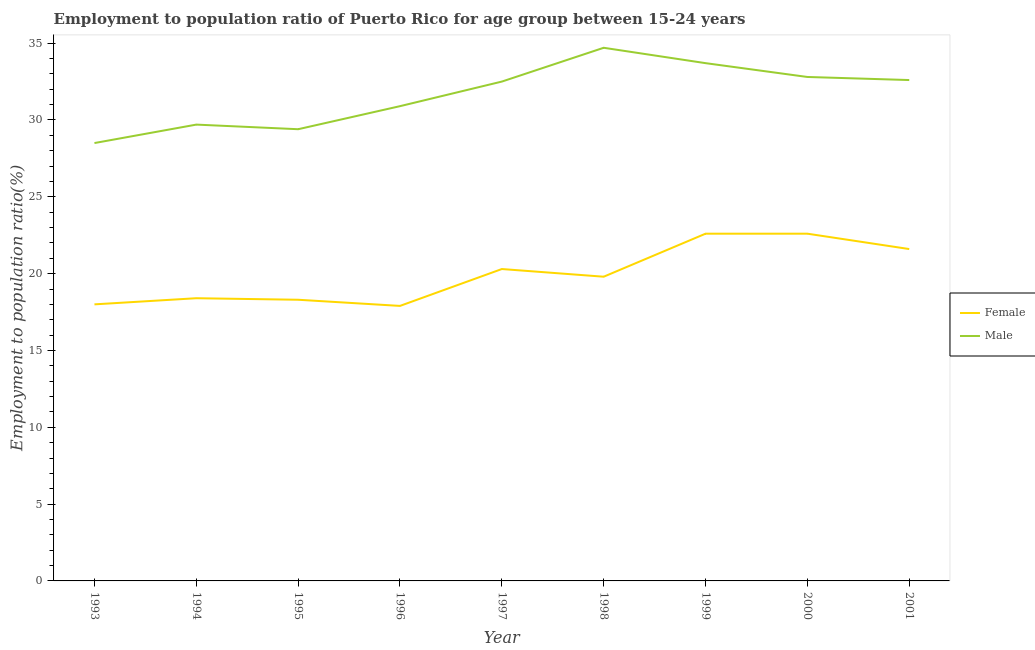How many different coloured lines are there?
Keep it short and to the point. 2. Does the line corresponding to employment to population ratio(female) intersect with the line corresponding to employment to population ratio(male)?
Keep it short and to the point. No. Is the number of lines equal to the number of legend labels?
Keep it short and to the point. Yes. What is the employment to population ratio(male) in 1993?
Your answer should be compact. 28.5. Across all years, what is the maximum employment to population ratio(female)?
Your response must be concise. 22.6. Across all years, what is the minimum employment to population ratio(female)?
Provide a short and direct response. 17.9. In which year was the employment to population ratio(female) minimum?
Your answer should be very brief. 1996. What is the total employment to population ratio(male) in the graph?
Your response must be concise. 284.8. What is the difference between the employment to population ratio(male) in 1995 and that in 2000?
Give a very brief answer. -3.4. What is the difference between the employment to population ratio(female) in 1996 and the employment to population ratio(male) in 2001?
Give a very brief answer. -14.7. What is the average employment to population ratio(female) per year?
Your answer should be compact. 19.94. In the year 1998, what is the difference between the employment to population ratio(male) and employment to population ratio(female)?
Your answer should be compact. 14.9. What is the ratio of the employment to population ratio(male) in 1994 to that in 2000?
Ensure brevity in your answer.  0.91. Is the employment to population ratio(female) in 1995 less than that in 1999?
Offer a terse response. Yes. Is the difference between the employment to population ratio(male) in 1996 and 1998 greater than the difference between the employment to population ratio(female) in 1996 and 1998?
Make the answer very short. No. What is the difference between the highest and the second highest employment to population ratio(female)?
Ensure brevity in your answer.  0. What is the difference between the highest and the lowest employment to population ratio(male)?
Keep it short and to the point. 6.2. In how many years, is the employment to population ratio(female) greater than the average employment to population ratio(female) taken over all years?
Offer a terse response. 4. Is the sum of the employment to population ratio(male) in 1995 and 1999 greater than the maximum employment to population ratio(female) across all years?
Ensure brevity in your answer.  Yes. Is the employment to population ratio(female) strictly greater than the employment to population ratio(male) over the years?
Offer a very short reply. No. Is the employment to population ratio(female) strictly less than the employment to population ratio(male) over the years?
Offer a very short reply. Yes. How many years are there in the graph?
Ensure brevity in your answer.  9. Are the values on the major ticks of Y-axis written in scientific E-notation?
Make the answer very short. No. Does the graph contain grids?
Offer a terse response. No. Where does the legend appear in the graph?
Give a very brief answer. Center right. How many legend labels are there?
Ensure brevity in your answer.  2. How are the legend labels stacked?
Offer a very short reply. Vertical. What is the title of the graph?
Keep it short and to the point. Employment to population ratio of Puerto Rico for age group between 15-24 years. What is the label or title of the X-axis?
Offer a very short reply. Year. What is the Employment to population ratio(%) in Female in 1993?
Ensure brevity in your answer.  18. What is the Employment to population ratio(%) of Female in 1994?
Your response must be concise. 18.4. What is the Employment to population ratio(%) in Male in 1994?
Ensure brevity in your answer.  29.7. What is the Employment to population ratio(%) of Female in 1995?
Make the answer very short. 18.3. What is the Employment to population ratio(%) in Male in 1995?
Ensure brevity in your answer.  29.4. What is the Employment to population ratio(%) of Female in 1996?
Offer a very short reply. 17.9. What is the Employment to population ratio(%) of Male in 1996?
Your answer should be very brief. 30.9. What is the Employment to population ratio(%) of Female in 1997?
Your answer should be very brief. 20.3. What is the Employment to population ratio(%) in Male in 1997?
Make the answer very short. 32.5. What is the Employment to population ratio(%) in Female in 1998?
Give a very brief answer. 19.8. What is the Employment to population ratio(%) in Male in 1998?
Keep it short and to the point. 34.7. What is the Employment to population ratio(%) of Female in 1999?
Your answer should be compact. 22.6. What is the Employment to population ratio(%) of Male in 1999?
Provide a succinct answer. 33.7. What is the Employment to population ratio(%) in Female in 2000?
Offer a very short reply. 22.6. What is the Employment to population ratio(%) in Male in 2000?
Give a very brief answer. 32.8. What is the Employment to population ratio(%) in Female in 2001?
Your response must be concise. 21.6. What is the Employment to population ratio(%) in Male in 2001?
Your response must be concise. 32.6. Across all years, what is the maximum Employment to population ratio(%) in Female?
Provide a short and direct response. 22.6. Across all years, what is the maximum Employment to population ratio(%) in Male?
Offer a terse response. 34.7. Across all years, what is the minimum Employment to population ratio(%) in Female?
Provide a succinct answer. 17.9. What is the total Employment to population ratio(%) in Female in the graph?
Your response must be concise. 179.5. What is the total Employment to population ratio(%) of Male in the graph?
Give a very brief answer. 284.8. What is the difference between the Employment to population ratio(%) of Male in 1993 and that in 1995?
Offer a very short reply. -0.9. What is the difference between the Employment to population ratio(%) in Male in 1993 and that in 1996?
Provide a short and direct response. -2.4. What is the difference between the Employment to population ratio(%) in Male in 1993 and that in 1997?
Ensure brevity in your answer.  -4. What is the difference between the Employment to population ratio(%) in Female in 1993 and that in 2000?
Provide a short and direct response. -4.6. What is the difference between the Employment to population ratio(%) of Male in 1993 and that in 2000?
Your answer should be compact. -4.3. What is the difference between the Employment to population ratio(%) in Female in 1993 and that in 2001?
Your answer should be compact. -3.6. What is the difference between the Employment to population ratio(%) of Female in 1994 and that in 1995?
Ensure brevity in your answer.  0.1. What is the difference between the Employment to population ratio(%) in Male in 1994 and that in 1995?
Your response must be concise. 0.3. What is the difference between the Employment to population ratio(%) of Male in 1994 and that in 1996?
Ensure brevity in your answer.  -1.2. What is the difference between the Employment to population ratio(%) in Female in 1994 and that in 1997?
Offer a terse response. -1.9. What is the difference between the Employment to population ratio(%) of Male in 1994 and that in 1997?
Make the answer very short. -2.8. What is the difference between the Employment to population ratio(%) of Female in 1994 and that in 2001?
Offer a very short reply. -3.2. What is the difference between the Employment to population ratio(%) of Male in 1995 and that in 1996?
Your response must be concise. -1.5. What is the difference between the Employment to population ratio(%) of Female in 1995 and that in 1997?
Provide a short and direct response. -2. What is the difference between the Employment to population ratio(%) of Male in 1995 and that in 1997?
Keep it short and to the point. -3.1. What is the difference between the Employment to population ratio(%) of Male in 1995 and that in 1999?
Make the answer very short. -4.3. What is the difference between the Employment to population ratio(%) of Female in 1995 and that in 2000?
Offer a very short reply. -4.3. What is the difference between the Employment to population ratio(%) of Male in 1995 and that in 2000?
Your response must be concise. -3.4. What is the difference between the Employment to population ratio(%) of Female in 1995 and that in 2001?
Ensure brevity in your answer.  -3.3. What is the difference between the Employment to population ratio(%) of Male in 1995 and that in 2001?
Offer a terse response. -3.2. What is the difference between the Employment to population ratio(%) in Male in 1996 and that in 1997?
Make the answer very short. -1.6. What is the difference between the Employment to population ratio(%) in Female in 1996 and that in 1998?
Give a very brief answer. -1.9. What is the difference between the Employment to population ratio(%) of Male in 1996 and that in 1998?
Make the answer very short. -3.8. What is the difference between the Employment to population ratio(%) in Female in 1996 and that in 1999?
Your answer should be very brief. -4.7. What is the difference between the Employment to population ratio(%) of Male in 1996 and that in 2001?
Offer a very short reply. -1.7. What is the difference between the Employment to population ratio(%) of Female in 1997 and that in 1998?
Give a very brief answer. 0.5. What is the difference between the Employment to population ratio(%) of Male in 1997 and that in 1998?
Ensure brevity in your answer.  -2.2. What is the difference between the Employment to population ratio(%) in Male in 1997 and that in 2000?
Provide a short and direct response. -0.3. What is the difference between the Employment to population ratio(%) of Female in 1997 and that in 2001?
Offer a terse response. -1.3. What is the difference between the Employment to population ratio(%) in Female in 1998 and that in 1999?
Your answer should be compact. -2.8. What is the difference between the Employment to population ratio(%) in Female in 1998 and that in 2001?
Give a very brief answer. -1.8. What is the difference between the Employment to population ratio(%) of Male in 1998 and that in 2001?
Ensure brevity in your answer.  2.1. What is the difference between the Employment to population ratio(%) of Male in 1999 and that in 2000?
Make the answer very short. 0.9. What is the difference between the Employment to population ratio(%) in Female in 1999 and that in 2001?
Give a very brief answer. 1. What is the difference between the Employment to population ratio(%) in Female in 1993 and the Employment to population ratio(%) in Male in 1995?
Offer a terse response. -11.4. What is the difference between the Employment to population ratio(%) of Female in 1993 and the Employment to population ratio(%) of Male in 1996?
Offer a very short reply. -12.9. What is the difference between the Employment to population ratio(%) of Female in 1993 and the Employment to population ratio(%) of Male in 1998?
Your answer should be compact. -16.7. What is the difference between the Employment to population ratio(%) in Female in 1993 and the Employment to population ratio(%) in Male in 1999?
Your answer should be very brief. -15.7. What is the difference between the Employment to population ratio(%) of Female in 1993 and the Employment to population ratio(%) of Male in 2000?
Provide a succinct answer. -14.8. What is the difference between the Employment to population ratio(%) of Female in 1993 and the Employment to population ratio(%) of Male in 2001?
Your answer should be compact. -14.6. What is the difference between the Employment to population ratio(%) in Female in 1994 and the Employment to population ratio(%) in Male in 1997?
Provide a succinct answer. -14.1. What is the difference between the Employment to population ratio(%) in Female in 1994 and the Employment to population ratio(%) in Male in 1998?
Give a very brief answer. -16.3. What is the difference between the Employment to population ratio(%) in Female in 1994 and the Employment to population ratio(%) in Male in 1999?
Provide a short and direct response. -15.3. What is the difference between the Employment to population ratio(%) of Female in 1994 and the Employment to population ratio(%) of Male in 2000?
Your answer should be compact. -14.4. What is the difference between the Employment to population ratio(%) in Female in 1994 and the Employment to population ratio(%) in Male in 2001?
Your response must be concise. -14.2. What is the difference between the Employment to population ratio(%) of Female in 1995 and the Employment to population ratio(%) of Male in 1998?
Provide a succinct answer. -16.4. What is the difference between the Employment to population ratio(%) of Female in 1995 and the Employment to population ratio(%) of Male in 1999?
Provide a succinct answer. -15.4. What is the difference between the Employment to population ratio(%) in Female in 1995 and the Employment to population ratio(%) in Male in 2001?
Provide a succinct answer. -14.3. What is the difference between the Employment to population ratio(%) in Female in 1996 and the Employment to population ratio(%) in Male in 1997?
Your answer should be compact. -14.6. What is the difference between the Employment to population ratio(%) in Female in 1996 and the Employment to population ratio(%) in Male in 1998?
Make the answer very short. -16.8. What is the difference between the Employment to population ratio(%) in Female in 1996 and the Employment to population ratio(%) in Male in 1999?
Your answer should be very brief. -15.8. What is the difference between the Employment to population ratio(%) in Female in 1996 and the Employment to population ratio(%) in Male in 2000?
Provide a succinct answer. -14.9. What is the difference between the Employment to population ratio(%) in Female in 1996 and the Employment to population ratio(%) in Male in 2001?
Your answer should be compact. -14.7. What is the difference between the Employment to population ratio(%) of Female in 1997 and the Employment to population ratio(%) of Male in 1998?
Keep it short and to the point. -14.4. What is the difference between the Employment to population ratio(%) in Female in 1997 and the Employment to population ratio(%) in Male in 1999?
Make the answer very short. -13.4. What is the difference between the Employment to population ratio(%) of Female in 1997 and the Employment to population ratio(%) of Male in 2000?
Make the answer very short. -12.5. What is the difference between the Employment to population ratio(%) in Female in 1997 and the Employment to population ratio(%) in Male in 2001?
Your answer should be compact. -12.3. What is the difference between the Employment to population ratio(%) in Female in 1998 and the Employment to population ratio(%) in Male in 2000?
Your answer should be very brief. -13. What is the difference between the Employment to population ratio(%) of Female in 1999 and the Employment to population ratio(%) of Male in 2000?
Your answer should be very brief. -10.2. What is the difference between the Employment to population ratio(%) in Female in 1999 and the Employment to population ratio(%) in Male in 2001?
Provide a short and direct response. -10. What is the average Employment to population ratio(%) of Female per year?
Offer a terse response. 19.94. What is the average Employment to population ratio(%) in Male per year?
Give a very brief answer. 31.64. In the year 1995, what is the difference between the Employment to population ratio(%) of Female and Employment to population ratio(%) of Male?
Offer a terse response. -11.1. In the year 1998, what is the difference between the Employment to population ratio(%) of Female and Employment to population ratio(%) of Male?
Provide a short and direct response. -14.9. In the year 2000, what is the difference between the Employment to population ratio(%) of Female and Employment to population ratio(%) of Male?
Your response must be concise. -10.2. In the year 2001, what is the difference between the Employment to population ratio(%) of Female and Employment to population ratio(%) of Male?
Your response must be concise. -11. What is the ratio of the Employment to population ratio(%) in Female in 1993 to that in 1994?
Offer a very short reply. 0.98. What is the ratio of the Employment to population ratio(%) in Male in 1993 to that in 1994?
Offer a very short reply. 0.96. What is the ratio of the Employment to population ratio(%) of Female in 1993 to that in 1995?
Ensure brevity in your answer.  0.98. What is the ratio of the Employment to population ratio(%) in Male in 1993 to that in 1995?
Offer a terse response. 0.97. What is the ratio of the Employment to population ratio(%) of Female in 1993 to that in 1996?
Provide a succinct answer. 1.01. What is the ratio of the Employment to population ratio(%) in Male in 1993 to that in 1996?
Your answer should be compact. 0.92. What is the ratio of the Employment to population ratio(%) in Female in 1993 to that in 1997?
Your answer should be very brief. 0.89. What is the ratio of the Employment to population ratio(%) in Male in 1993 to that in 1997?
Your answer should be very brief. 0.88. What is the ratio of the Employment to population ratio(%) of Male in 1993 to that in 1998?
Make the answer very short. 0.82. What is the ratio of the Employment to population ratio(%) in Female in 1993 to that in 1999?
Offer a terse response. 0.8. What is the ratio of the Employment to population ratio(%) in Male in 1993 to that in 1999?
Provide a succinct answer. 0.85. What is the ratio of the Employment to population ratio(%) of Female in 1993 to that in 2000?
Make the answer very short. 0.8. What is the ratio of the Employment to population ratio(%) of Male in 1993 to that in 2000?
Provide a succinct answer. 0.87. What is the ratio of the Employment to population ratio(%) of Female in 1993 to that in 2001?
Offer a terse response. 0.83. What is the ratio of the Employment to population ratio(%) in Male in 1993 to that in 2001?
Provide a short and direct response. 0.87. What is the ratio of the Employment to population ratio(%) of Female in 1994 to that in 1995?
Give a very brief answer. 1.01. What is the ratio of the Employment to population ratio(%) in Male in 1994 to that in 1995?
Offer a terse response. 1.01. What is the ratio of the Employment to population ratio(%) in Female in 1994 to that in 1996?
Your answer should be compact. 1.03. What is the ratio of the Employment to population ratio(%) in Male in 1994 to that in 1996?
Keep it short and to the point. 0.96. What is the ratio of the Employment to population ratio(%) in Female in 1994 to that in 1997?
Give a very brief answer. 0.91. What is the ratio of the Employment to population ratio(%) of Male in 1994 to that in 1997?
Your response must be concise. 0.91. What is the ratio of the Employment to population ratio(%) of Female in 1994 to that in 1998?
Ensure brevity in your answer.  0.93. What is the ratio of the Employment to population ratio(%) of Male in 1994 to that in 1998?
Your answer should be compact. 0.86. What is the ratio of the Employment to population ratio(%) of Female in 1994 to that in 1999?
Offer a terse response. 0.81. What is the ratio of the Employment to population ratio(%) in Male in 1994 to that in 1999?
Offer a very short reply. 0.88. What is the ratio of the Employment to population ratio(%) in Female in 1994 to that in 2000?
Your answer should be very brief. 0.81. What is the ratio of the Employment to population ratio(%) of Male in 1994 to that in 2000?
Ensure brevity in your answer.  0.91. What is the ratio of the Employment to population ratio(%) of Female in 1994 to that in 2001?
Your response must be concise. 0.85. What is the ratio of the Employment to population ratio(%) of Male in 1994 to that in 2001?
Your answer should be compact. 0.91. What is the ratio of the Employment to population ratio(%) of Female in 1995 to that in 1996?
Your answer should be very brief. 1.02. What is the ratio of the Employment to population ratio(%) in Male in 1995 to that in 1996?
Your answer should be compact. 0.95. What is the ratio of the Employment to population ratio(%) of Female in 1995 to that in 1997?
Your answer should be very brief. 0.9. What is the ratio of the Employment to population ratio(%) in Male in 1995 to that in 1997?
Your response must be concise. 0.9. What is the ratio of the Employment to population ratio(%) in Female in 1995 to that in 1998?
Keep it short and to the point. 0.92. What is the ratio of the Employment to population ratio(%) in Male in 1995 to that in 1998?
Make the answer very short. 0.85. What is the ratio of the Employment to population ratio(%) of Female in 1995 to that in 1999?
Keep it short and to the point. 0.81. What is the ratio of the Employment to population ratio(%) in Male in 1995 to that in 1999?
Your answer should be very brief. 0.87. What is the ratio of the Employment to population ratio(%) in Female in 1995 to that in 2000?
Ensure brevity in your answer.  0.81. What is the ratio of the Employment to population ratio(%) in Male in 1995 to that in 2000?
Make the answer very short. 0.9. What is the ratio of the Employment to population ratio(%) of Female in 1995 to that in 2001?
Keep it short and to the point. 0.85. What is the ratio of the Employment to population ratio(%) of Male in 1995 to that in 2001?
Ensure brevity in your answer.  0.9. What is the ratio of the Employment to population ratio(%) in Female in 1996 to that in 1997?
Give a very brief answer. 0.88. What is the ratio of the Employment to population ratio(%) in Male in 1996 to that in 1997?
Ensure brevity in your answer.  0.95. What is the ratio of the Employment to population ratio(%) of Female in 1996 to that in 1998?
Offer a terse response. 0.9. What is the ratio of the Employment to population ratio(%) in Male in 1996 to that in 1998?
Make the answer very short. 0.89. What is the ratio of the Employment to population ratio(%) of Female in 1996 to that in 1999?
Make the answer very short. 0.79. What is the ratio of the Employment to population ratio(%) in Male in 1996 to that in 1999?
Offer a terse response. 0.92. What is the ratio of the Employment to population ratio(%) of Female in 1996 to that in 2000?
Your response must be concise. 0.79. What is the ratio of the Employment to population ratio(%) in Male in 1996 to that in 2000?
Give a very brief answer. 0.94. What is the ratio of the Employment to population ratio(%) of Female in 1996 to that in 2001?
Give a very brief answer. 0.83. What is the ratio of the Employment to population ratio(%) in Male in 1996 to that in 2001?
Provide a short and direct response. 0.95. What is the ratio of the Employment to population ratio(%) in Female in 1997 to that in 1998?
Provide a succinct answer. 1.03. What is the ratio of the Employment to population ratio(%) of Male in 1997 to that in 1998?
Offer a very short reply. 0.94. What is the ratio of the Employment to population ratio(%) in Female in 1997 to that in 1999?
Your response must be concise. 0.9. What is the ratio of the Employment to population ratio(%) in Male in 1997 to that in 1999?
Make the answer very short. 0.96. What is the ratio of the Employment to population ratio(%) in Female in 1997 to that in 2000?
Offer a very short reply. 0.9. What is the ratio of the Employment to population ratio(%) in Male in 1997 to that in 2000?
Ensure brevity in your answer.  0.99. What is the ratio of the Employment to population ratio(%) in Female in 1997 to that in 2001?
Your response must be concise. 0.94. What is the ratio of the Employment to population ratio(%) in Female in 1998 to that in 1999?
Keep it short and to the point. 0.88. What is the ratio of the Employment to population ratio(%) of Male in 1998 to that in 1999?
Your response must be concise. 1.03. What is the ratio of the Employment to population ratio(%) in Female in 1998 to that in 2000?
Give a very brief answer. 0.88. What is the ratio of the Employment to population ratio(%) of Male in 1998 to that in 2000?
Make the answer very short. 1.06. What is the ratio of the Employment to population ratio(%) of Male in 1998 to that in 2001?
Your answer should be very brief. 1.06. What is the ratio of the Employment to population ratio(%) of Female in 1999 to that in 2000?
Keep it short and to the point. 1. What is the ratio of the Employment to population ratio(%) of Male in 1999 to that in 2000?
Your response must be concise. 1.03. What is the ratio of the Employment to population ratio(%) of Female in 1999 to that in 2001?
Provide a short and direct response. 1.05. What is the ratio of the Employment to population ratio(%) in Male in 1999 to that in 2001?
Your answer should be compact. 1.03. What is the ratio of the Employment to population ratio(%) of Female in 2000 to that in 2001?
Provide a short and direct response. 1.05. What is the difference between the highest and the second highest Employment to population ratio(%) of Female?
Keep it short and to the point. 0. What is the difference between the highest and the second highest Employment to population ratio(%) of Male?
Keep it short and to the point. 1. 